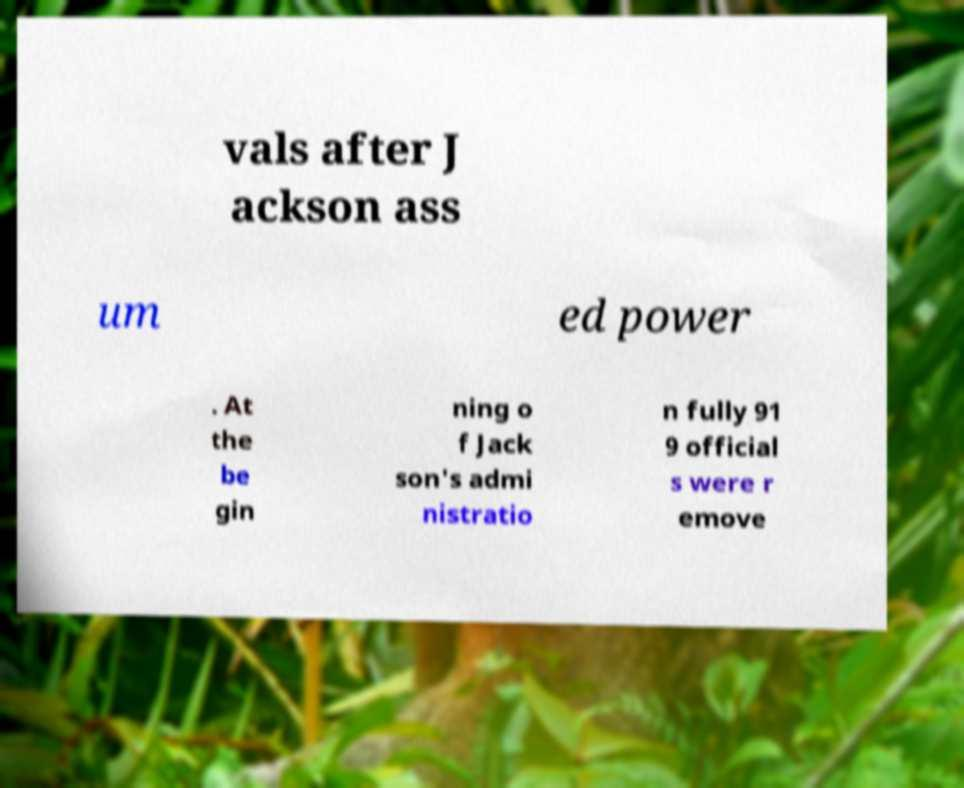Can you read and provide the text displayed in the image?This photo seems to have some interesting text. Can you extract and type it out for me? vals after J ackson ass um ed power . At the be gin ning o f Jack son's admi nistratio n fully 91 9 official s were r emove 